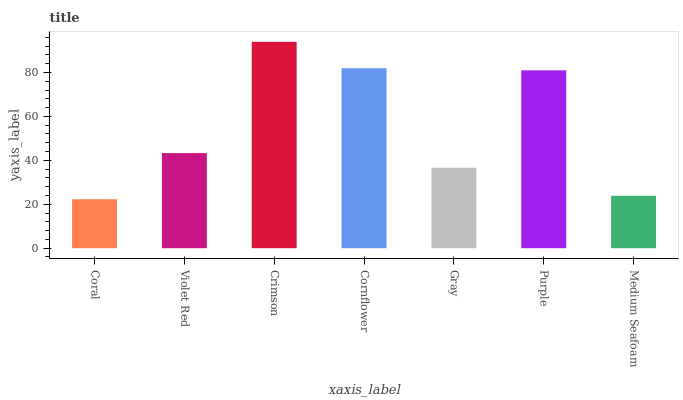Is Coral the minimum?
Answer yes or no. Yes. Is Crimson the maximum?
Answer yes or no. Yes. Is Violet Red the minimum?
Answer yes or no. No. Is Violet Red the maximum?
Answer yes or no. No. Is Violet Red greater than Coral?
Answer yes or no. Yes. Is Coral less than Violet Red?
Answer yes or no. Yes. Is Coral greater than Violet Red?
Answer yes or no. No. Is Violet Red less than Coral?
Answer yes or no. No. Is Violet Red the high median?
Answer yes or no. Yes. Is Violet Red the low median?
Answer yes or no. Yes. Is Cornflower the high median?
Answer yes or no. No. Is Cornflower the low median?
Answer yes or no. No. 